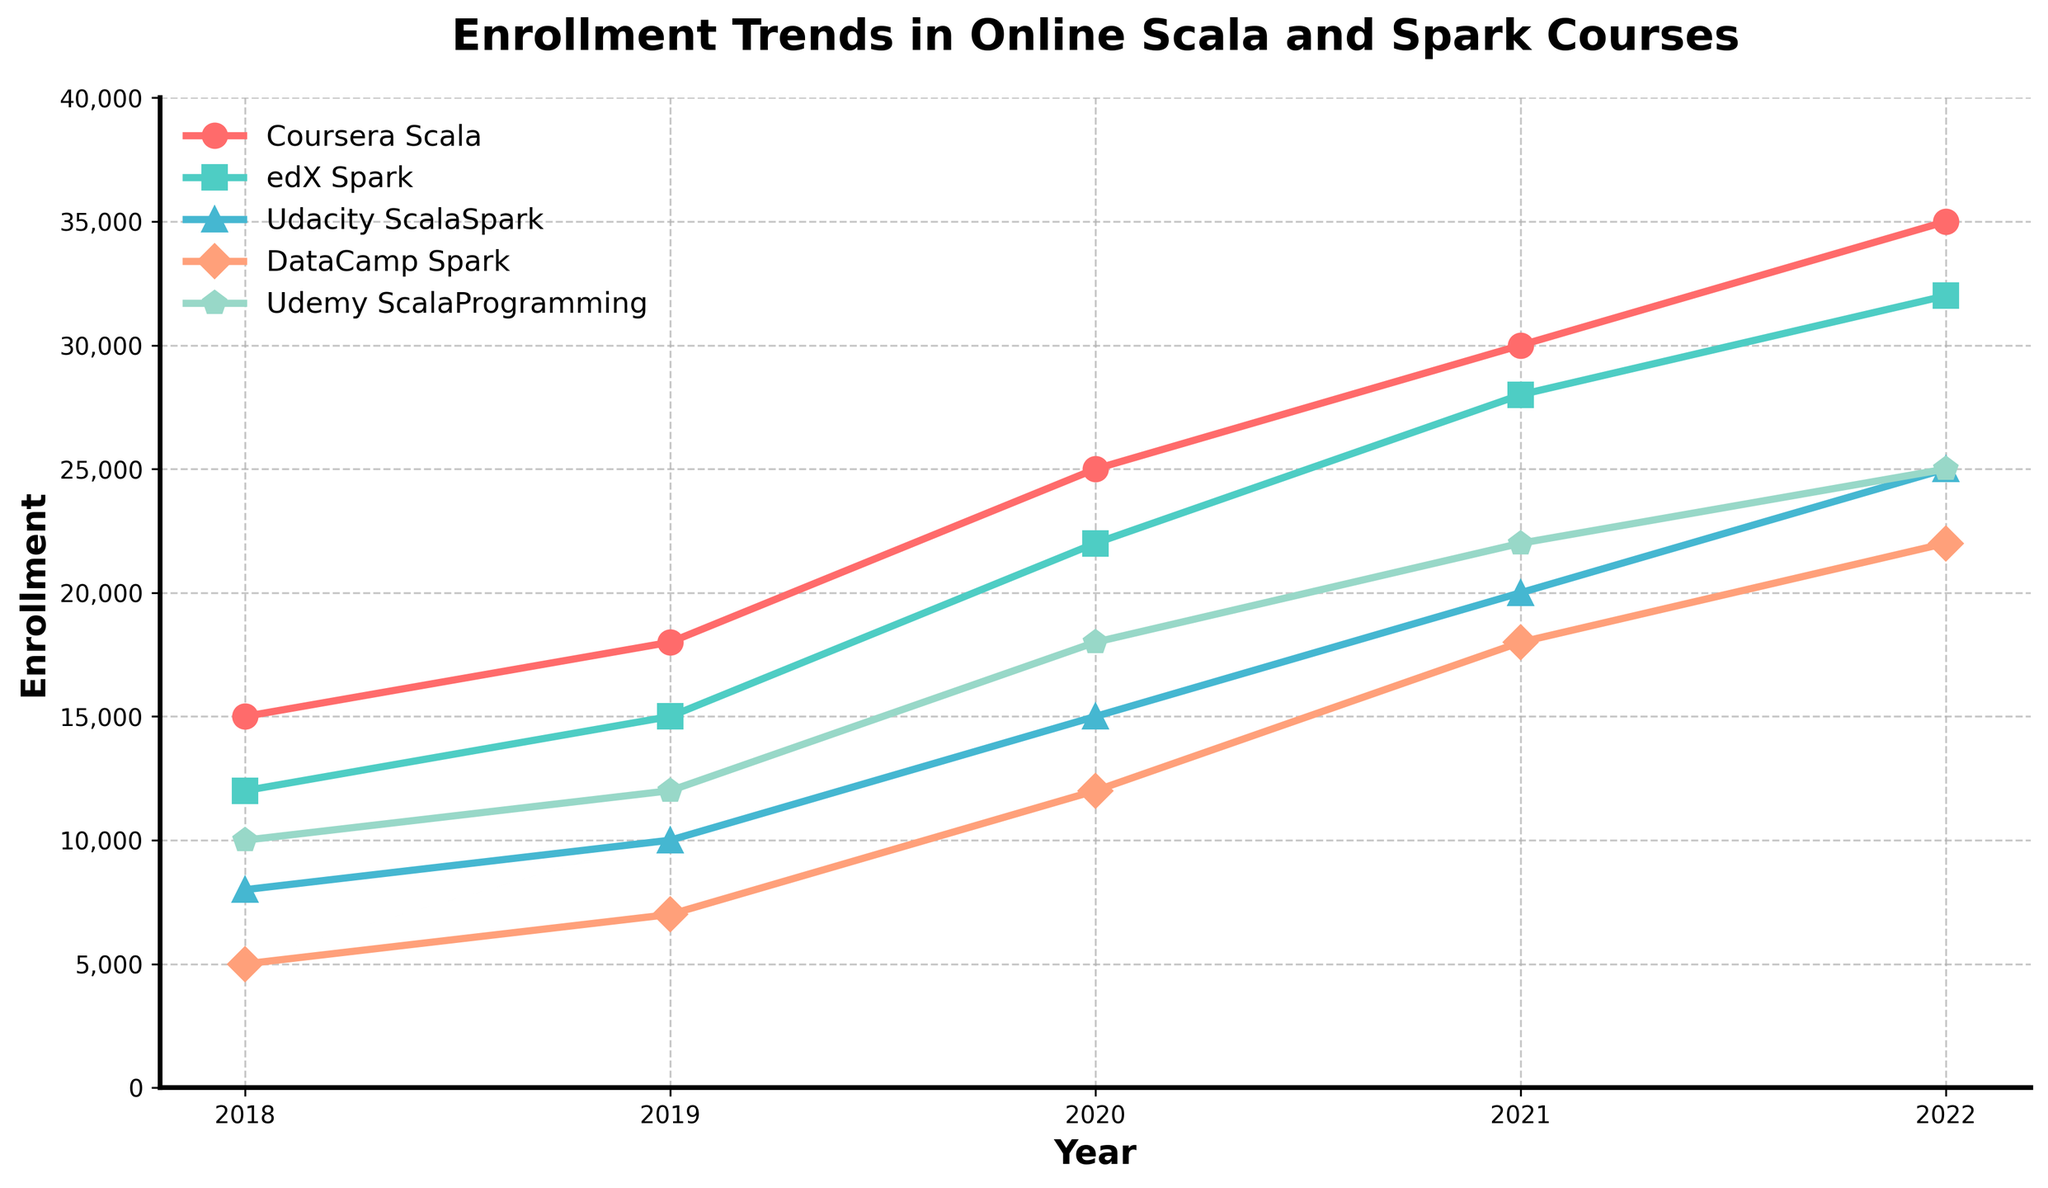Which platform had the highest enrollment in 2022? In 2022, the blue line representing Coursera Scala is plotted at the highest point compared to the other lines for that year.
Answer: Coursera Scala Which years saw the highest enrollment increase for edX Spark? By evaluating the slope of the light green line for edX Spark, the increase from 2019 to 2020 and from 2020 to 2021 are both substantial. A sharp rise between 2019 to 2020 and a consistent rise between 2020 to 2021 show high enrollment increases.
Answer: 2019-2020 and 2020-2021 How did Udacity ScalaSpark enrollment change from 2018 to 2022? From the orange line representing Udacity ScalaSpark, the enrollment clearly increased every year, starting at 8,000 in 2018 and going up to 25,000 in 2022. The line shows a consistent upwards trend each year.
Answer: It increased every year What was the average enrollment in DataCamp Spark courses across all years? Adding the enrollment numbers for DataCamp Spark across all years (5000, 7000, 12000, 18000, 22000) gives a total of 64,000. Dividing by 5 years, the average enrollment is 12,800.
Answer: 12,800 Which two platforms had similar enrollment numbers in 2021, and what were those numbers? In 2021, both Udacity ScalaSpark (dark blue line) and DataCamp Spark (dark salmon line) had enrollments close to each other. Udacity ScalaSpark and DataCamp Spark had 20,000 and 18,000 enrollments, respectively, making these numbers similar.
Answer: Udacity ScalaSpark and DataCamp Spark; 20,000 and 18,000 How much did the enrollment for Udemy Scala Programming change from 2020 to 2021? In 2020, the green line for Udemy Scala Programming shows an enrollment of 18,000. By 2021, this value increased to 22,000, resulting in a change of 22,000 - 18,000 = 4,000.
Answer: 4,000 Which platform witnessed a steady increase in enrollment without any dips, and what is the progression trend? By looking at the lines, Coursera Scala (red line) showed a steady increase in enrollment each year without any dips, going from 15,000 in 2018 to 35,000 in 2022.
Answer: Coursera Scala; Steady increase Which year's Udemy Scala Programming enrollment is approximately the average enrollment of all platforms in 2019? The average enrollment for all platforms in 2019 is (18000 + 15000 + 10000 + 7000 + 12000) / 5 = 12400. According to the green line, Udemy Scala Programming's enrollment was just above the average at 12,000 in 2019, which is approximately the average enrollment.
Answer: 2019 